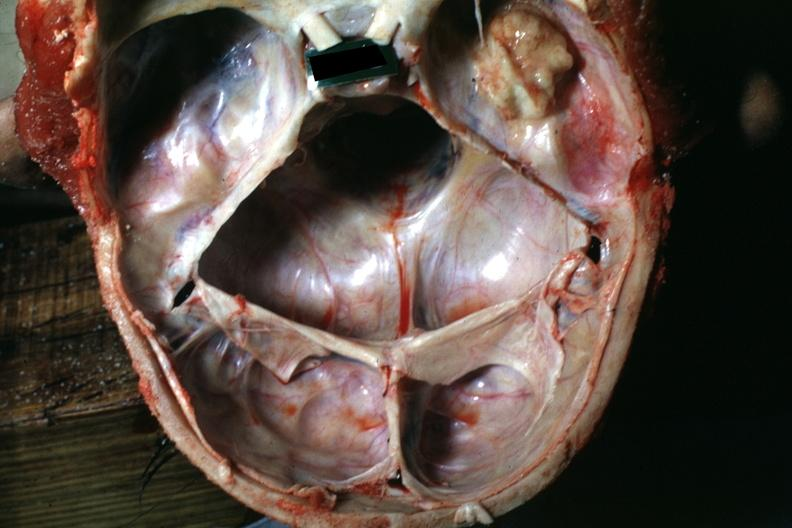what is present?
Answer the question using a single word or phrase. Bone 